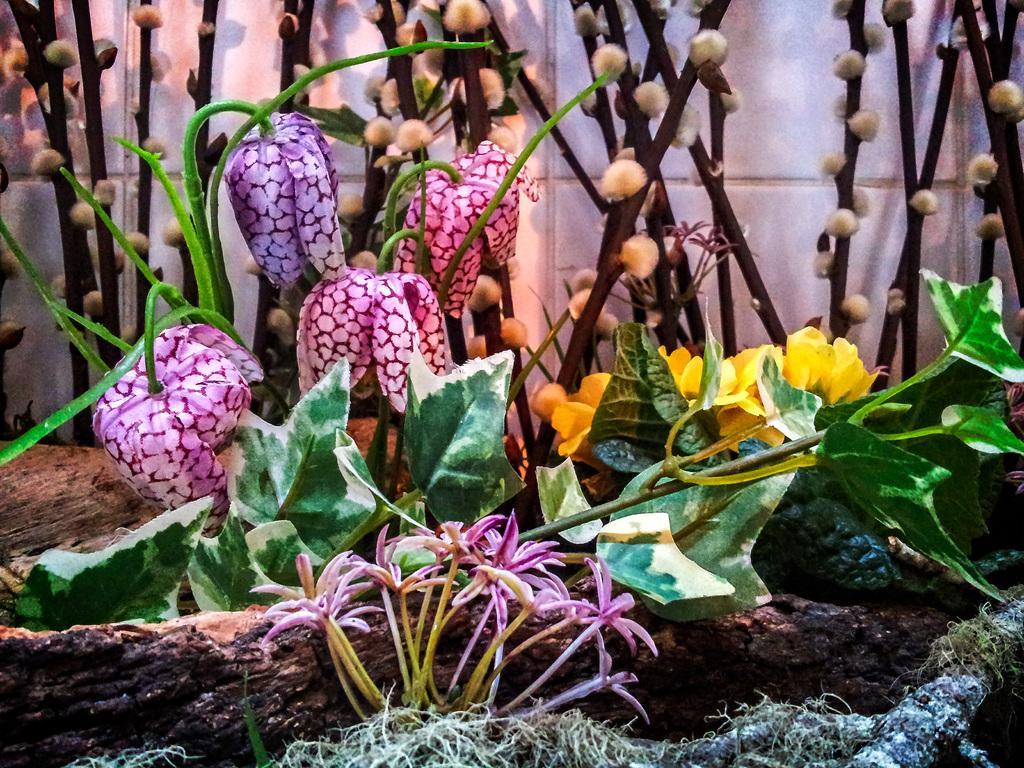Could you give a brief overview of what you see in this image? In this picture I can see few plants with flowers and I can see a tree bark and few flowers are yellow and purple in color and I can see a wall. 